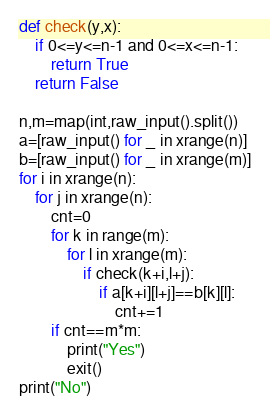<code> <loc_0><loc_0><loc_500><loc_500><_Python_>def check(y,x):
    if 0<=y<=n-1 and 0<=x<=n-1:
        return True
    return False

n,m=map(int,raw_input().split())
a=[raw_input() for _ in xrange(n)]
b=[raw_input() for _ in xrange(m)]
for i in xrange(n):
    for j in xrange(n):
        cnt=0
        for k in range(m):
            for l in xrange(m):
                if check(k+i,l+j):
                    if a[k+i][l+j]==b[k][l]:
                        cnt+=1
        if cnt==m*m:
            print("Yes")
            exit()
print("No")
</code> 